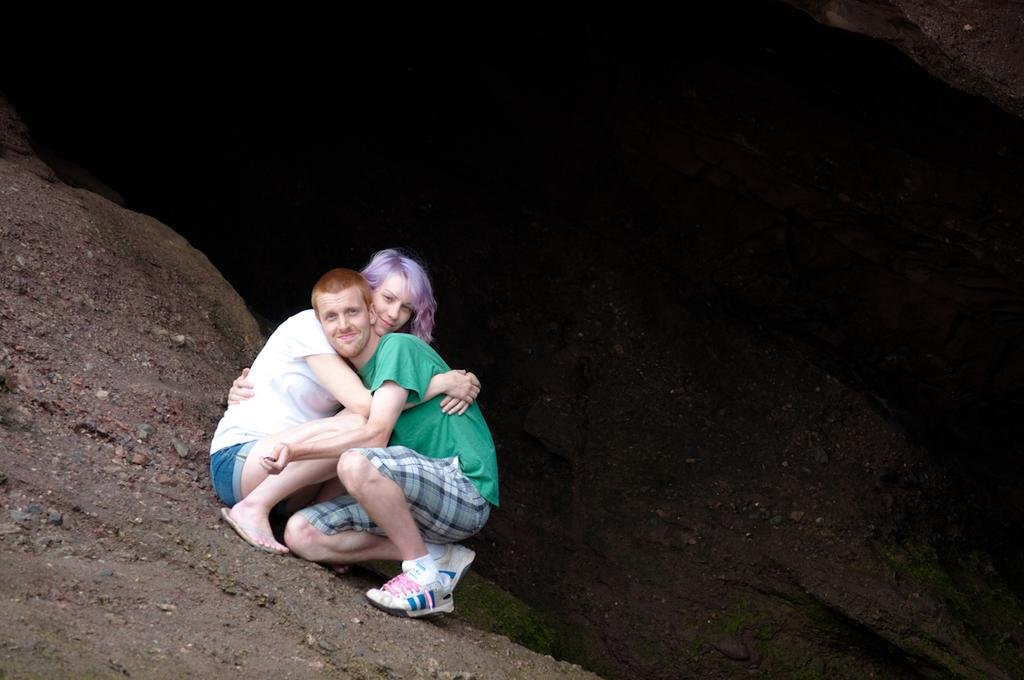Who are the two people in the center of the image? There is a man and a woman in the center of the image. What are the man and woman doing in the image? The man and woman are hugging each other. What type of terrain is visible at the bottom of the image? There is sand at the bottom of the image. What can be seen in the distance in the background of the image? There is a mountain in the background of the image. What type of trees can be seen in the image? There are no trees visible in the image; it features a man and a woman hugging each other, sand at the bottom, and a mountain in the background. What kind of music is the man playing on his guitar in the image? There is no guitar present in the image; it only features a man and a woman hugging each other, sand at the bottom, and a mountain in the background. 